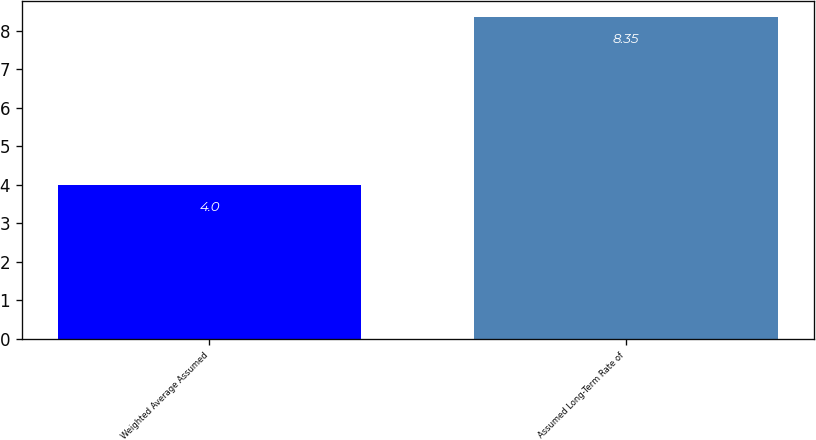<chart> <loc_0><loc_0><loc_500><loc_500><bar_chart><fcel>Weighted Average Assumed<fcel>Assumed Long-Term Rate of<nl><fcel>4<fcel>8.35<nl></chart> 